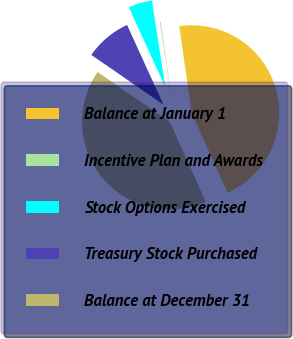Convert chart. <chart><loc_0><loc_0><loc_500><loc_500><pie_chart><fcel>Balance at January 1<fcel>Incentive Plan and Awards<fcel>Stock Options Exercised<fcel>Treasury Stock Purchased<fcel>Balance at December 31<nl><fcel>45.53%<fcel>0.19%<fcel>4.38%<fcel>8.57%<fcel>41.34%<nl></chart> 